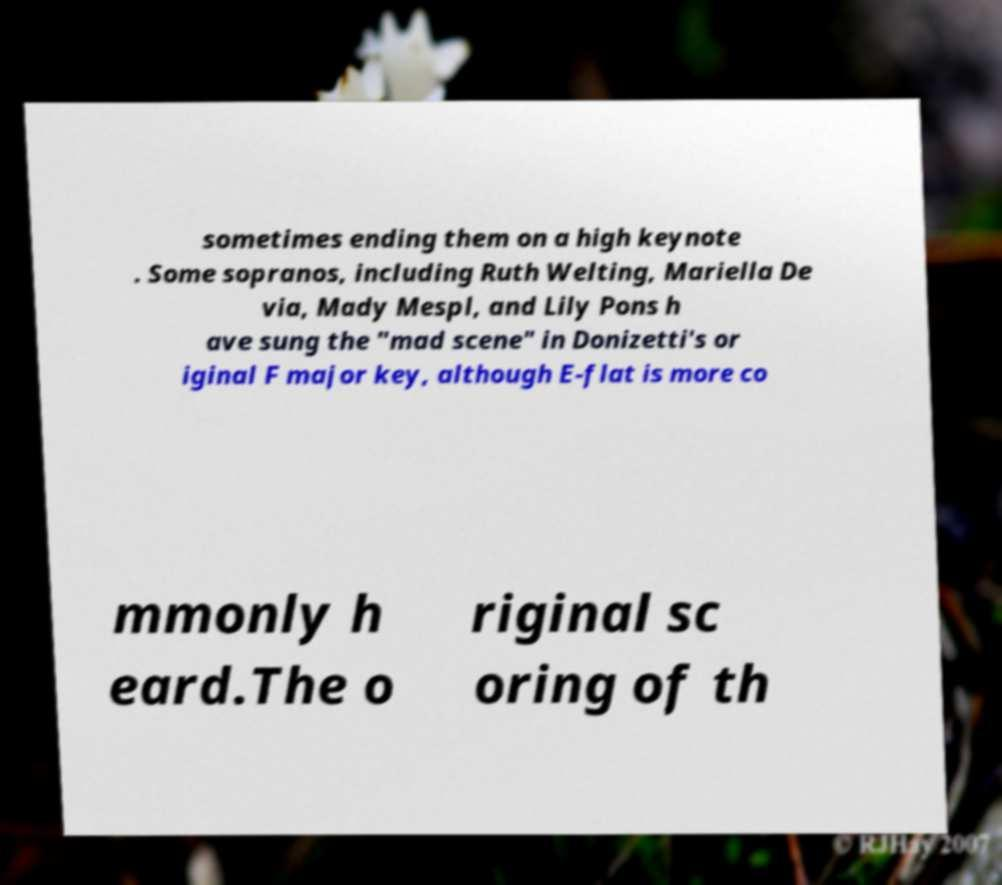Can you accurately transcribe the text from the provided image for me? sometimes ending them on a high keynote . Some sopranos, including Ruth Welting, Mariella De via, Mady Mespl, and Lily Pons h ave sung the "mad scene" in Donizetti's or iginal F major key, although E-flat is more co mmonly h eard.The o riginal sc oring of th 